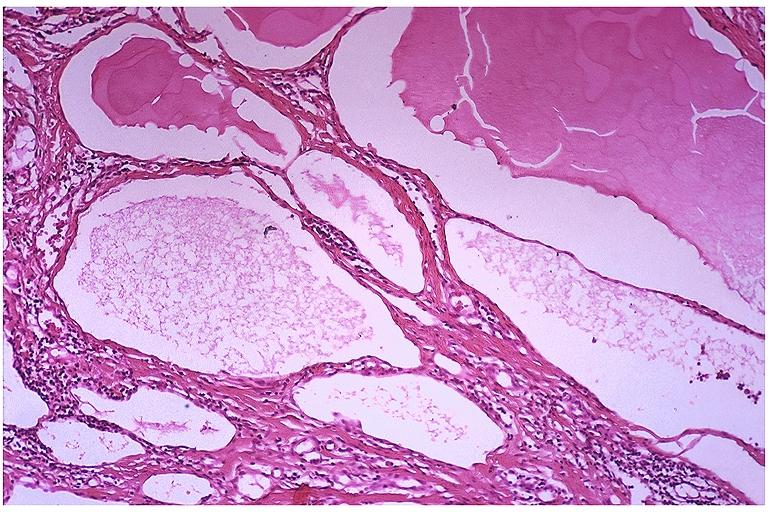where is this?
Answer the question using a single word or phrase. Oral 